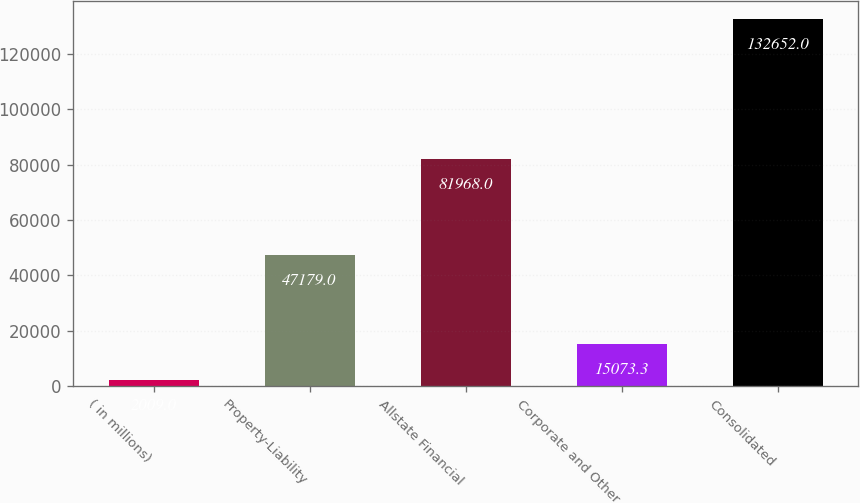<chart> <loc_0><loc_0><loc_500><loc_500><bar_chart><fcel>( in millions)<fcel>Property-Liability<fcel>Allstate Financial<fcel>Corporate and Other<fcel>Consolidated<nl><fcel>2009<fcel>47179<fcel>81968<fcel>15073.3<fcel>132652<nl></chart> 